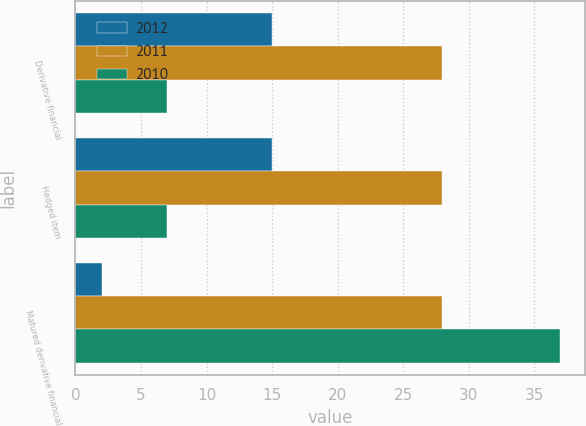Convert chart to OTSL. <chart><loc_0><loc_0><loc_500><loc_500><stacked_bar_chart><ecel><fcel>Derivative financial<fcel>Hedged item<fcel>Matured derivative financial<nl><fcel>2012<fcel>15<fcel>15<fcel>2<nl><fcel>2011<fcel>28<fcel>28<fcel>28<nl><fcel>2010<fcel>7<fcel>7<fcel>37<nl></chart> 